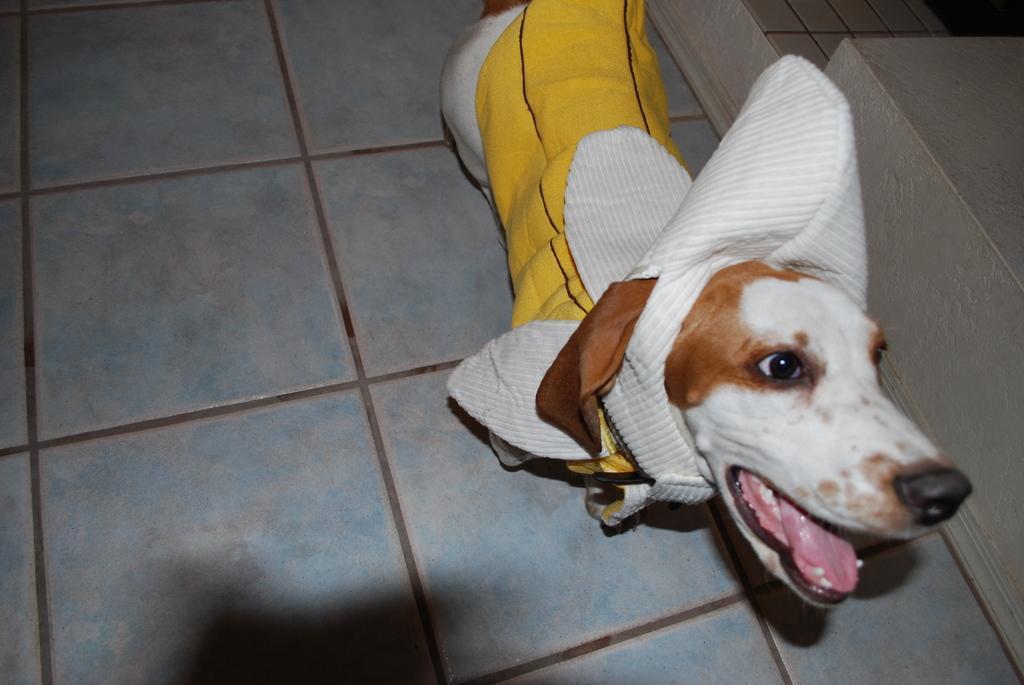In one or two sentences, can you explain what this image depicts? In this image I can see a dog is there, it wore yellow and white color cloth. 